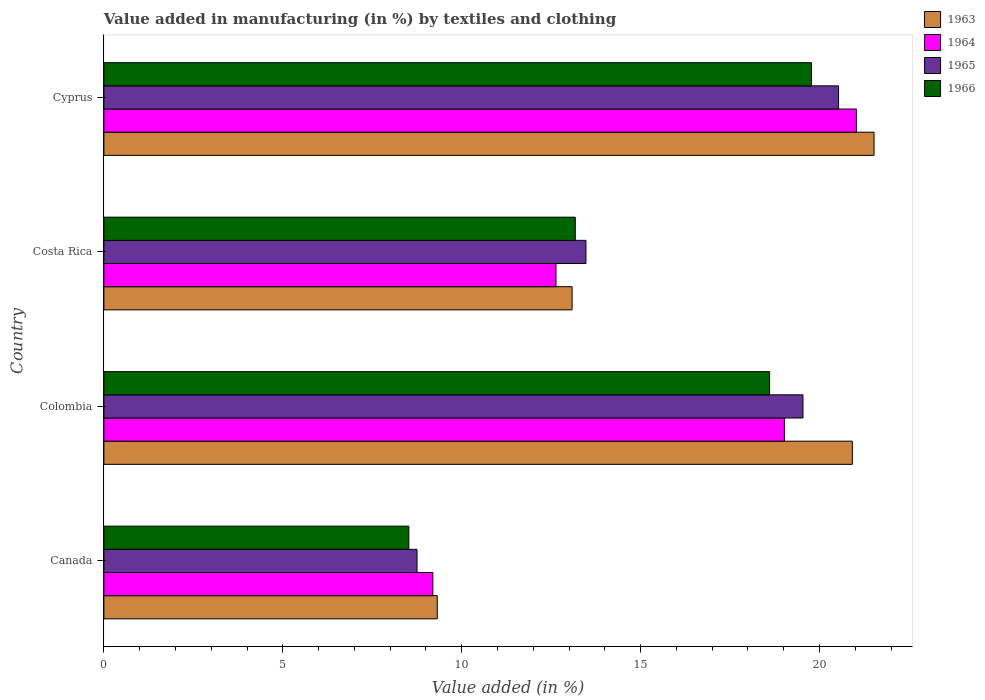How many different coloured bars are there?
Your response must be concise. 4. Are the number of bars on each tick of the Y-axis equal?
Offer a terse response. Yes. How many bars are there on the 2nd tick from the top?
Offer a terse response. 4. How many bars are there on the 1st tick from the bottom?
Your answer should be compact. 4. What is the label of the 3rd group of bars from the top?
Provide a succinct answer. Colombia. What is the percentage of value added in manufacturing by textiles and clothing in 1964 in Costa Rica?
Your answer should be compact. 12.63. Across all countries, what is the maximum percentage of value added in manufacturing by textiles and clothing in 1966?
Your answer should be very brief. 19.78. Across all countries, what is the minimum percentage of value added in manufacturing by textiles and clothing in 1964?
Give a very brief answer. 9.19. In which country was the percentage of value added in manufacturing by textiles and clothing in 1964 maximum?
Your answer should be compact. Cyprus. In which country was the percentage of value added in manufacturing by textiles and clothing in 1964 minimum?
Make the answer very short. Canada. What is the total percentage of value added in manufacturing by textiles and clothing in 1965 in the graph?
Offer a terse response. 62.29. What is the difference between the percentage of value added in manufacturing by textiles and clothing in 1963 in Canada and that in Costa Rica?
Make the answer very short. -3.77. What is the difference between the percentage of value added in manufacturing by textiles and clothing in 1965 in Cyprus and the percentage of value added in manufacturing by textiles and clothing in 1966 in Canada?
Offer a very short reply. 12.01. What is the average percentage of value added in manufacturing by textiles and clothing in 1965 per country?
Make the answer very short. 15.57. What is the difference between the percentage of value added in manufacturing by textiles and clothing in 1966 and percentage of value added in manufacturing by textiles and clothing in 1963 in Costa Rica?
Offer a terse response. 0.09. In how many countries, is the percentage of value added in manufacturing by textiles and clothing in 1964 greater than 13 %?
Make the answer very short. 2. What is the ratio of the percentage of value added in manufacturing by textiles and clothing in 1964 in Colombia to that in Cyprus?
Provide a succinct answer. 0.9. Is the percentage of value added in manufacturing by textiles and clothing in 1963 in Costa Rica less than that in Cyprus?
Provide a succinct answer. Yes. What is the difference between the highest and the second highest percentage of value added in manufacturing by textiles and clothing in 1964?
Make the answer very short. 2.01. What is the difference between the highest and the lowest percentage of value added in manufacturing by textiles and clothing in 1963?
Make the answer very short. 12.21. In how many countries, is the percentage of value added in manufacturing by textiles and clothing in 1966 greater than the average percentage of value added in manufacturing by textiles and clothing in 1966 taken over all countries?
Keep it short and to the point. 2. Is the sum of the percentage of value added in manufacturing by textiles and clothing in 1964 in Costa Rica and Cyprus greater than the maximum percentage of value added in manufacturing by textiles and clothing in 1966 across all countries?
Offer a very short reply. Yes. Is it the case that in every country, the sum of the percentage of value added in manufacturing by textiles and clothing in 1964 and percentage of value added in manufacturing by textiles and clothing in 1965 is greater than the sum of percentage of value added in manufacturing by textiles and clothing in 1963 and percentage of value added in manufacturing by textiles and clothing in 1966?
Your response must be concise. No. What does the 3rd bar from the top in Canada represents?
Your response must be concise. 1964. Is it the case that in every country, the sum of the percentage of value added in manufacturing by textiles and clothing in 1966 and percentage of value added in manufacturing by textiles and clothing in 1965 is greater than the percentage of value added in manufacturing by textiles and clothing in 1964?
Keep it short and to the point. Yes. Are all the bars in the graph horizontal?
Make the answer very short. Yes. How many countries are there in the graph?
Your response must be concise. 4. What is the difference between two consecutive major ticks on the X-axis?
Ensure brevity in your answer.  5. Are the values on the major ticks of X-axis written in scientific E-notation?
Your answer should be very brief. No. Does the graph contain grids?
Give a very brief answer. No. Where does the legend appear in the graph?
Give a very brief answer. Top right. What is the title of the graph?
Your answer should be very brief. Value added in manufacturing (in %) by textiles and clothing. What is the label or title of the X-axis?
Make the answer very short. Value added (in %). What is the label or title of the Y-axis?
Keep it short and to the point. Country. What is the Value added (in %) of 1963 in Canada?
Make the answer very short. 9.32. What is the Value added (in %) of 1964 in Canada?
Make the answer very short. 9.19. What is the Value added (in %) of 1965 in Canada?
Your answer should be very brief. 8.75. What is the Value added (in %) in 1966 in Canada?
Your answer should be compact. 8.52. What is the Value added (in %) of 1963 in Colombia?
Give a very brief answer. 20.92. What is the Value added (in %) of 1964 in Colombia?
Your answer should be compact. 19.02. What is the Value added (in %) in 1965 in Colombia?
Provide a succinct answer. 19.54. What is the Value added (in %) in 1966 in Colombia?
Provide a succinct answer. 18.6. What is the Value added (in %) of 1963 in Costa Rica?
Your response must be concise. 13.08. What is the Value added (in %) in 1964 in Costa Rica?
Your response must be concise. 12.63. What is the Value added (in %) of 1965 in Costa Rica?
Offer a terse response. 13.47. What is the Value added (in %) of 1966 in Costa Rica?
Your response must be concise. 13.17. What is the Value added (in %) of 1963 in Cyprus?
Give a very brief answer. 21.52. What is the Value added (in %) in 1964 in Cyprus?
Keep it short and to the point. 21.03. What is the Value added (in %) of 1965 in Cyprus?
Offer a very short reply. 20.53. What is the Value added (in %) of 1966 in Cyprus?
Your answer should be very brief. 19.78. Across all countries, what is the maximum Value added (in %) of 1963?
Make the answer very short. 21.52. Across all countries, what is the maximum Value added (in %) of 1964?
Offer a terse response. 21.03. Across all countries, what is the maximum Value added (in %) in 1965?
Offer a terse response. 20.53. Across all countries, what is the maximum Value added (in %) in 1966?
Your response must be concise. 19.78. Across all countries, what is the minimum Value added (in %) of 1963?
Give a very brief answer. 9.32. Across all countries, what is the minimum Value added (in %) in 1964?
Provide a succinct answer. 9.19. Across all countries, what is the minimum Value added (in %) of 1965?
Provide a succinct answer. 8.75. Across all countries, what is the minimum Value added (in %) of 1966?
Keep it short and to the point. 8.52. What is the total Value added (in %) in 1963 in the graph?
Give a very brief answer. 64.84. What is the total Value added (in %) of 1964 in the graph?
Offer a terse response. 61.88. What is the total Value added (in %) of 1965 in the graph?
Give a very brief answer. 62.29. What is the total Value added (in %) in 1966 in the graph?
Keep it short and to the point. 60.08. What is the difference between the Value added (in %) in 1963 in Canada and that in Colombia?
Make the answer very short. -11.6. What is the difference between the Value added (in %) of 1964 in Canada and that in Colombia?
Provide a succinct answer. -9.82. What is the difference between the Value added (in %) of 1965 in Canada and that in Colombia?
Give a very brief answer. -10.79. What is the difference between the Value added (in %) in 1966 in Canada and that in Colombia?
Provide a short and direct response. -10.08. What is the difference between the Value added (in %) of 1963 in Canada and that in Costa Rica?
Keep it short and to the point. -3.77. What is the difference between the Value added (in %) in 1964 in Canada and that in Costa Rica?
Give a very brief answer. -3.44. What is the difference between the Value added (in %) in 1965 in Canada and that in Costa Rica?
Your response must be concise. -4.72. What is the difference between the Value added (in %) of 1966 in Canada and that in Costa Rica?
Keep it short and to the point. -4.65. What is the difference between the Value added (in %) of 1963 in Canada and that in Cyprus?
Provide a short and direct response. -12.21. What is the difference between the Value added (in %) of 1964 in Canada and that in Cyprus?
Your answer should be compact. -11.84. What is the difference between the Value added (in %) of 1965 in Canada and that in Cyprus?
Make the answer very short. -11.78. What is the difference between the Value added (in %) of 1966 in Canada and that in Cyprus?
Your response must be concise. -11.25. What is the difference between the Value added (in %) in 1963 in Colombia and that in Costa Rica?
Offer a terse response. 7.83. What is the difference between the Value added (in %) of 1964 in Colombia and that in Costa Rica?
Your answer should be very brief. 6.38. What is the difference between the Value added (in %) of 1965 in Colombia and that in Costa Rica?
Give a very brief answer. 6.06. What is the difference between the Value added (in %) in 1966 in Colombia and that in Costa Rica?
Provide a succinct answer. 5.43. What is the difference between the Value added (in %) of 1963 in Colombia and that in Cyprus?
Keep it short and to the point. -0.61. What is the difference between the Value added (in %) in 1964 in Colombia and that in Cyprus?
Your response must be concise. -2.01. What is the difference between the Value added (in %) in 1965 in Colombia and that in Cyprus?
Your answer should be compact. -0.99. What is the difference between the Value added (in %) of 1966 in Colombia and that in Cyprus?
Provide a short and direct response. -1.17. What is the difference between the Value added (in %) of 1963 in Costa Rica and that in Cyprus?
Your answer should be compact. -8.44. What is the difference between the Value added (in %) of 1964 in Costa Rica and that in Cyprus?
Keep it short and to the point. -8.4. What is the difference between the Value added (in %) of 1965 in Costa Rica and that in Cyprus?
Give a very brief answer. -7.06. What is the difference between the Value added (in %) in 1966 in Costa Rica and that in Cyprus?
Your answer should be very brief. -6.6. What is the difference between the Value added (in %) of 1963 in Canada and the Value added (in %) of 1964 in Colombia?
Offer a terse response. -9.7. What is the difference between the Value added (in %) of 1963 in Canada and the Value added (in %) of 1965 in Colombia?
Offer a terse response. -10.22. What is the difference between the Value added (in %) in 1963 in Canada and the Value added (in %) in 1966 in Colombia?
Provide a short and direct response. -9.29. What is the difference between the Value added (in %) of 1964 in Canada and the Value added (in %) of 1965 in Colombia?
Keep it short and to the point. -10.34. What is the difference between the Value added (in %) of 1964 in Canada and the Value added (in %) of 1966 in Colombia?
Offer a very short reply. -9.41. What is the difference between the Value added (in %) in 1965 in Canada and the Value added (in %) in 1966 in Colombia?
Ensure brevity in your answer.  -9.85. What is the difference between the Value added (in %) in 1963 in Canada and the Value added (in %) in 1964 in Costa Rica?
Offer a very short reply. -3.32. What is the difference between the Value added (in %) of 1963 in Canada and the Value added (in %) of 1965 in Costa Rica?
Your answer should be compact. -4.16. What is the difference between the Value added (in %) of 1963 in Canada and the Value added (in %) of 1966 in Costa Rica?
Your response must be concise. -3.86. What is the difference between the Value added (in %) in 1964 in Canada and the Value added (in %) in 1965 in Costa Rica?
Offer a terse response. -4.28. What is the difference between the Value added (in %) in 1964 in Canada and the Value added (in %) in 1966 in Costa Rica?
Your answer should be compact. -3.98. What is the difference between the Value added (in %) in 1965 in Canada and the Value added (in %) in 1966 in Costa Rica?
Make the answer very short. -4.42. What is the difference between the Value added (in %) in 1963 in Canada and the Value added (in %) in 1964 in Cyprus?
Your response must be concise. -11.71. What is the difference between the Value added (in %) of 1963 in Canada and the Value added (in %) of 1965 in Cyprus?
Your answer should be very brief. -11.21. What is the difference between the Value added (in %) in 1963 in Canada and the Value added (in %) in 1966 in Cyprus?
Your answer should be very brief. -10.46. What is the difference between the Value added (in %) in 1964 in Canada and the Value added (in %) in 1965 in Cyprus?
Ensure brevity in your answer.  -11.34. What is the difference between the Value added (in %) of 1964 in Canada and the Value added (in %) of 1966 in Cyprus?
Make the answer very short. -10.58. What is the difference between the Value added (in %) in 1965 in Canada and the Value added (in %) in 1966 in Cyprus?
Offer a terse response. -11.02. What is the difference between the Value added (in %) of 1963 in Colombia and the Value added (in %) of 1964 in Costa Rica?
Ensure brevity in your answer.  8.28. What is the difference between the Value added (in %) of 1963 in Colombia and the Value added (in %) of 1965 in Costa Rica?
Your answer should be very brief. 7.44. What is the difference between the Value added (in %) of 1963 in Colombia and the Value added (in %) of 1966 in Costa Rica?
Your answer should be very brief. 7.74. What is the difference between the Value added (in %) of 1964 in Colombia and the Value added (in %) of 1965 in Costa Rica?
Offer a terse response. 5.55. What is the difference between the Value added (in %) in 1964 in Colombia and the Value added (in %) in 1966 in Costa Rica?
Provide a short and direct response. 5.84. What is the difference between the Value added (in %) of 1965 in Colombia and the Value added (in %) of 1966 in Costa Rica?
Your answer should be compact. 6.36. What is the difference between the Value added (in %) of 1963 in Colombia and the Value added (in %) of 1964 in Cyprus?
Your response must be concise. -0.11. What is the difference between the Value added (in %) in 1963 in Colombia and the Value added (in %) in 1965 in Cyprus?
Offer a very short reply. 0.39. What is the difference between the Value added (in %) of 1963 in Colombia and the Value added (in %) of 1966 in Cyprus?
Your answer should be very brief. 1.14. What is the difference between the Value added (in %) in 1964 in Colombia and the Value added (in %) in 1965 in Cyprus?
Your answer should be compact. -1.51. What is the difference between the Value added (in %) of 1964 in Colombia and the Value added (in %) of 1966 in Cyprus?
Make the answer very short. -0.76. What is the difference between the Value added (in %) of 1965 in Colombia and the Value added (in %) of 1966 in Cyprus?
Keep it short and to the point. -0.24. What is the difference between the Value added (in %) in 1963 in Costa Rica and the Value added (in %) in 1964 in Cyprus?
Keep it short and to the point. -7.95. What is the difference between the Value added (in %) of 1963 in Costa Rica and the Value added (in %) of 1965 in Cyprus?
Offer a very short reply. -7.45. What is the difference between the Value added (in %) in 1963 in Costa Rica and the Value added (in %) in 1966 in Cyprus?
Make the answer very short. -6.69. What is the difference between the Value added (in %) in 1964 in Costa Rica and the Value added (in %) in 1965 in Cyprus?
Give a very brief answer. -7.9. What is the difference between the Value added (in %) of 1964 in Costa Rica and the Value added (in %) of 1966 in Cyprus?
Keep it short and to the point. -7.14. What is the difference between the Value added (in %) of 1965 in Costa Rica and the Value added (in %) of 1966 in Cyprus?
Your answer should be very brief. -6.3. What is the average Value added (in %) of 1963 per country?
Ensure brevity in your answer.  16.21. What is the average Value added (in %) in 1964 per country?
Your answer should be very brief. 15.47. What is the average Value added (in %) of 1965 per country?
Offer a very short reply. 15.57. What is the average Value added (in %) in 1966 per country?
Provide a succinct answer. 15.02. What is the difference between the Value added (in %) in 1963 and Value added (in %) in 1964 in Canada?
Your response must be concise. 0.12. What is the difference between the Value added (in %) of 1963 and Value added (in %) of 1965 in Canada?
Provide a succinct answer. 0.57. What is the difference between the Value added (in %) of 1963 and Value added (in %) of 1966 in Canada?
Your answer should be compact. 0.8. What is the difference between the Value added (in %) in 1964 and Value added (in %) in 1965 in Canada?
Make the answer very short. 0.44. What is the difference between the Value added (in %) in 1964 and Value added (in %) in 1966 in Canada?
Provide a short and direct response. 0.67. What is the difference between the Value added (in %) of 1965 and Value added (in %) of 1966 in Canada?
Make the answer very short. 0.23. What is the difference between the Value added (in %) in 1963 and Value added (in %) in 1964 in Colombia?
Your answer should be very brief. 1.9. What is the difference between the Value added (in %) of 1963 and Value added (in %) of 1965 in Colombia?
Provide a short and direct response. 1.38. What is the difference between the Value added (in %) of 1963 and Value added (in %) of 1966 in Colombia?
Your answer should be very brief. 2.31. What is the difference between the Value added (in %) in 1964 and Value added (in %) in 1965 in Colombia?
Your answer should be very brief. -0.52. What is the difference between the Value added (in %) of 1964 and Value added (in %) of 1966 in Colombia?
Provide a succinct answer. 0.41. What is the difference between the Value added (in %) in 1965 and Value added (in %) in 1966 in Colombia?
Offer a terse response. 0.93. What is the difference between the Value added (in %) of 1963 and Value added (in %) of 1964 in Costa Rica?
Ensure brevity in your answer.  0.45. What is the difference between the Value added (in %) of 1963 and Value added (in %) of 1965 in Costa Rica?
Ensure brevity in your answer.  -0.39. What is the difference between the Value added (in %) in 1963 and Value added (in %) in 1966 in Costa Rica?
Keep it short and to the point. -0.09. What is the difference between the Value added (in %) of 1964 and Value added (in %) of 1965 in Costa Rica?
Your answer should be very brief. -0.84. What is the difference between the Value added (in %) in 1964 and Value added (in %) in 1966 in Costa Rica?
Make the answer very short. -0.54. What is the difference between the Value added (in %) of 1965 and Value added (in %) of 1966 in Costa Rica?
Offer a terse response. 0.3. What is the difference between the Value added (in %) of 1963 and Value added (in %) of 1964 in Cyprus?
Keep it short and to the point. 0.49. What is the difference between the Value added (in %) of 1963 and Value added (in %) of 1965 in Cyprus?
Provide a short and direct response. 0.99. What is the difference between the Value added (in %) in 1963 and Value added (in %) in 1966 in Cyprus?
Your answer should be very brief. 1.75. What is the difference between the Value added (in %) in 1964 and Value added (in %) in 1965 in Cyprus?
Your response must be concise. 0.5. What is the difference between the Value added (in %) of 1964 and Value added (in %) of 1966 in Cyprus?
Offer a very short reply. 1.25. What is the difference between the Value added (in %) of 1965 and Value added (in %) of 1966 in Cyprus?
Provide a short and direct response. 0.76. What is the ratio of the Value added (in %) in 1963 in Canada to that in Colombia?
Ensure brevity in your answer.  0.45. What is the ratio of the Value added (in %) of 1964 in Canada to that in Colombia?
Provide a short and direct response. 0.48. What is the ratio of the Value added (in %) in 1965 in Canada to that in Colombia?
Your answer should be very brief. 0.45. What is the ratio of the Value added (in %) of 1966 in Canada to that in Colombia?
Make the answer very short. 0.46. What is the ratio of the Value added (in %) in 1963 in Canada to that in Costa Rica?
Make the answer very short. 0.71. What is the ratio of the Value added (in %) in 1964 in Canada to that in Costa Rica?
Offer a terse response. 0.73. What is the ratio of the Value added (in %) in 1965 in Canada to that in Costa Rica?
Keep it short and to the point. 0.65. What is the ratio of the Value added (in %) in 1966 in Canada to that in Costa Rica?
Provide a succinct answer. 0.65. What is the ratio of the Value added (in %) of 1963 in Canada to that in Cyprus?
Your answer should be very brief. 0.43. What is the ratio of the Value added (in %) in 1964 in Canada to that in Cyprus?
Make the answer very short. 0.44. What is the ratio of the Value added (in %) in 1965 in Canada to that in Cyprus?
Keep it short and to the point. 0.43. What is the ratio of the Value added (in %) in 1966 in Canada to that in Cyprus?
Keep it short and to the point. 0.43. What is the ratio of the Value added (in %) of 1963 in Colombia to that in Costa Rica?
Ensure brevity in your answer.  1.6. What is the ratio of the Value added (in %) in 1964 in Colombia to that in Costa Rica?
Offer a terse response. 1.51. What is the ratio of the Value added (in %) of 1965 in Colombia to that in Costa Rica?
Keep it short and to the point. 1.45. What is the ratio of the Value added (in %) in 1966 in Colombia to that in Costa Rica?
Keep it short and to the point. 1.41. What is the ratio of the Value added (in %) in 1963 in Colombia to that in Cyprus?
Ensure brevity in your answer.  0.97. What is the ratio of the Value added (in %) in 1964 in Colombia to that in Cyprus?
Offer a very short reply. 0.9. What is the ratio of the Value added (in %) of 1965 in Colombia to that in Cyprus?
Offer a terse response. 0.95. What is the ratio of the Value added (in %) in 1966 in Colombia to that in Cyprus?
Give a very brief answer. 0.94. What is the ratio of the Value added (in %) of 1963 in Costa Rica to that in Cyprus?
Your answer should be very brief. 0.61. What is the ratio of the Value added (in %) in 1964 in Costa Rica to that in Cyprus?
Offer a very short reply. 0.6. What is the ratio of the Value added (in %) of 1965 in Costa Rica to that in Cyprus?
Your answer should be compact. 0.66. What is the ratio of the Value added (in %) of 1966 in Costa Rica to that in Cyprus?
Your response must be concise. 0.67. What is the difference between the highest and the second highest Value added (in %) in 1963?
Your answer should be compact. 0.61. What is the difference between the highest and the second highest Value added (in %) in 1964?
Your answer should be compact. 2.01. What is the difference between the highest and the second highest Value added (in %) in 1966?
Give a very brief answer. 1.17. What is the difference between the highest and the lowest Value added (in %) in 1963?
Your answer should be very brief. 12.21. What is the difference between the highest and the lowest Value added (in %) of 1964?
Offer a very short reply. 11.84. What is the difference between the highest and the lowest Value added (in %) of 1965?
Provide a succinct answer. 11.78. What is the difference between the highest and the lowest Value added (in %) in 1966?
Provide a short and direct response. 11.25. 